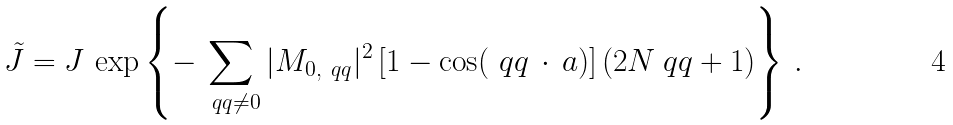<formula> <loc_0><loc_0><loc_500><loc_500>\tilde { J } = J \, \exp \left \{ - \sum _ { \ q q \neq 0 } | M _ { 0 , \ q q } | ^ { 2 } \left [ 1 - \cos ( \ q q \, \cdot \, a ) \right ] \left ( 2 N _ { \ } q q + 1 \right ) \right \} \, .</formula> 